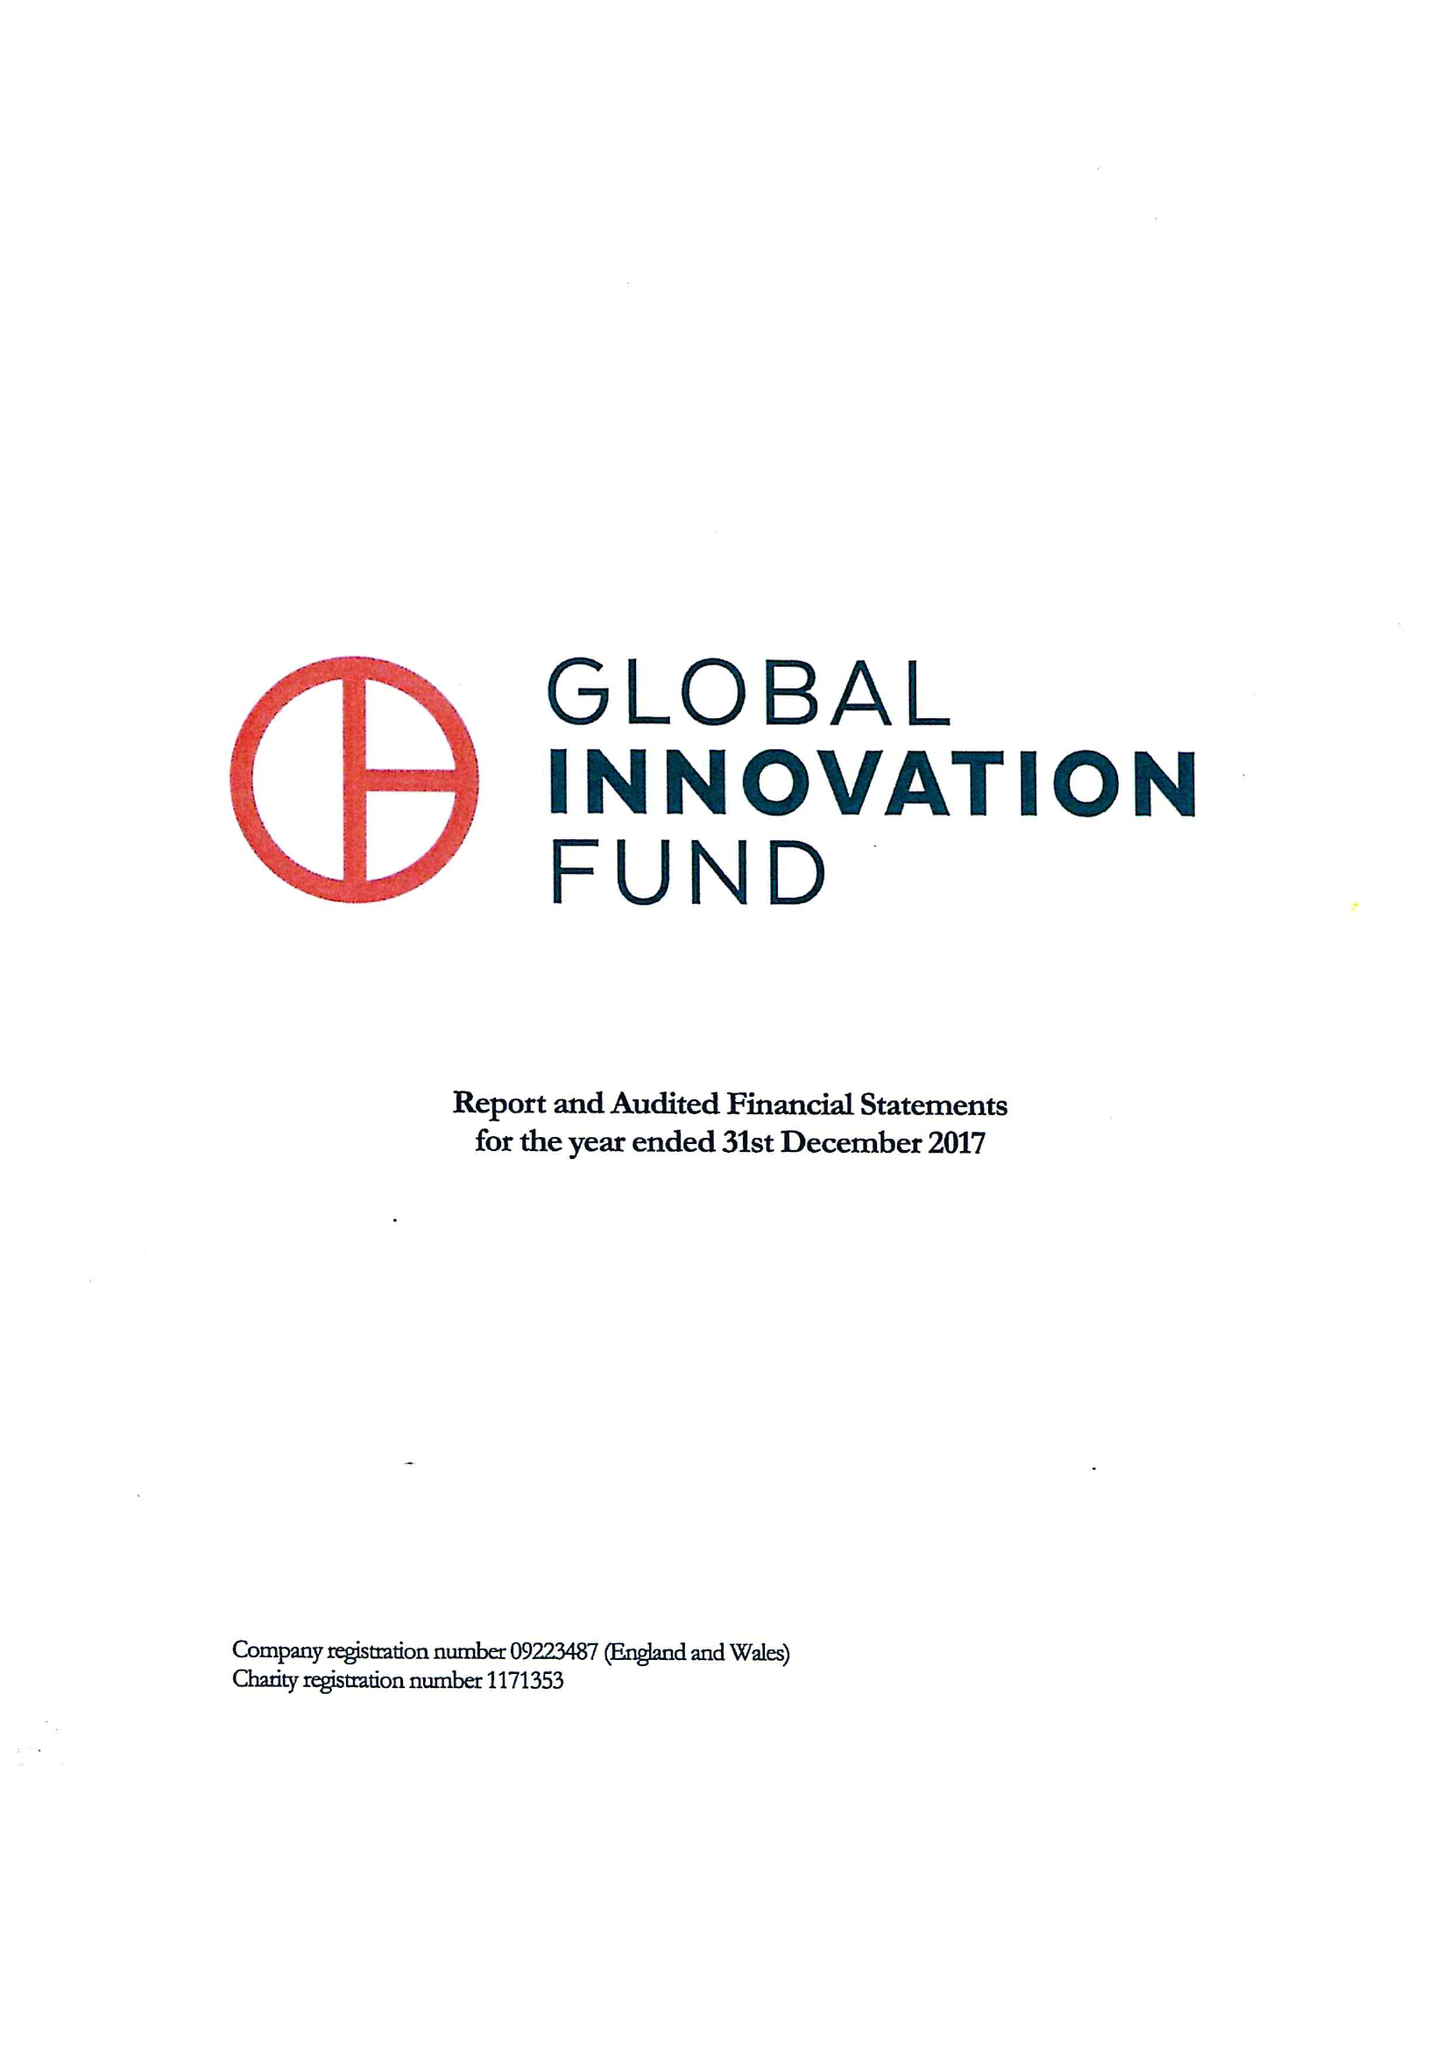What is the value for the address__street_line?
Answer the question using a single word or phrase. 68-80 HANBURY STREET 